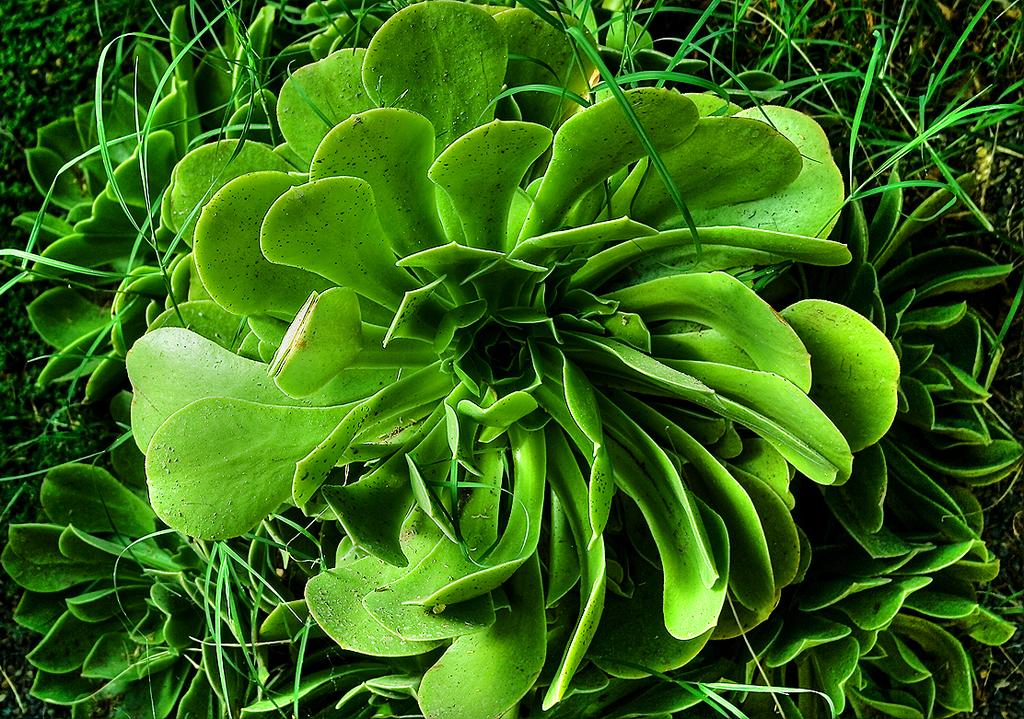What type of plants can be seen in the image? There are green color plants in the image. What type of soup is being served by the fireman in the image? There is no fireman or soup present in the image; it only features green color plants. 